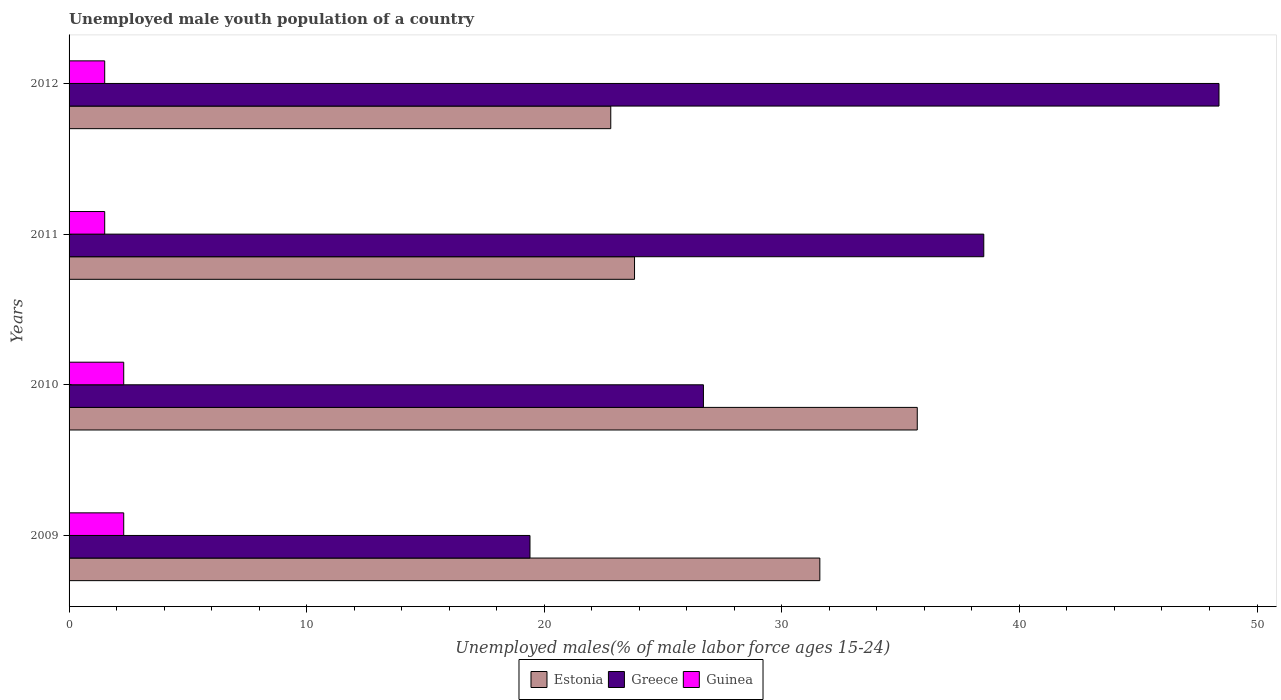How many different coloured bars are there?
Provide a short and direct response. 3. How many groups of bars are there?
Keep it short and to the point. 4. Are the number of bars per tick equal to the number of legend labels?
Make the answer very short. Yes. Are the number of bars on each tick of the Y-axis equal?
Provide a succinct answer. Yes. How many bars are there on the 2nd tick from the top?
Make the answer very short. 3. How many bars are there on the 3rd tick from the bottom?
Ensure brevity in your answer.  3. What is the percentage of unemployed male youth population in Guinea in 2009?
Give a very brief answer. 2.3. Across all years, what is the maximum percentage of unemployed male youth population in Guinea?
Your response must be concise. 2.3. Across all years, what is the minimum percentage of unemployed male youth population in Greece?
Ensure brevity in your answer.  19.4. In which year was the percentage of unemployed male youth population in Guinea maximum?
Keep it short and to the point. 2009. What is the total percentage of unemployed male youth population in Greece in the graph?
Ensure brevity in your answer.  133. What is the difference between the percentage of unemployed male youth population in Estonia in 2009 and that in 2010?
Provide a short and direct response. -4.1. What is the difference between the percentage of unemployed male youth population in Estonia in 2010 and the percentage of unemployed male youth population in Guinea in 2012?
Make the answer very short. 34.2. What is the average percentage of unemployed male youth population in Estonia per year?
Give a very brief answer. 28.47. In the year 2012, what is the difference between the percentage of unemployed male youth population in Guinea and percentage of unemployed male youth population in Estonia?
Ensure brevity in your answer.  -21.3. In how many years, is the percentage of unemployed male youth population in Guinea greater than 46 %?
Make the answer very short. 0. What is the ratio of the percentage of unemployed male youth population in Greece in 2009 to that in 2012?
Provide a succinct answer. 0.4. Is the percentage of unemployed male youth population in Estonia in 2010 less than that in 2012?
Your response must be concise. No. Is the difference between the percentage of unemployed male youth population in Guinea in 2010 and 2011 greater than the difference between the percentage of unemployed male youth population in Estonia in 2010 and 2011?
Offer a very short reply. No. What is the difference between the highest and the second highest percentage of unemployed male youth population in Guinea?
Give a very brief answer. 0. What is the difference between the highest and the lowest percentage of unemployed male youth population in Greece?
Make the answer very short. 29. What does the 1st bar from the top in 2010 represents?
Make the answer very short. Guinea. Are the values on the major ticks of X-axis written in scientific E-notation?
Give a very brief answer. No. Does the graph contain any zero values?
Make the answer very short. No. Does the graph contain grids?
Offer a terse response. No. Where does the legend appear in the graph?
Your answer should be compact. Bottom center. What is the title of the graph?
Offer a terse response. Unemployed male youth population of a country. What is the label or title of the X-axis?
Give a very brief answer. Unemployed males(% of male labor force ages 15-24). What is the Unemployed males(% of male labor force ages 15-24) of Estonia in 2009?
Provide a short and direct response. 31.6. What is the Unemployed males(% of male labor force ages 15-24) in Greece in 2009?
Your response must be concise. 19.4. What is the Unemployed males(% of male labor force ages 15-24) of Guinea in 2009?
Provide a short and direct response. 2.3. What is the Unemployed males(% of male labor force ages 15-24) in Estonia in 2010?
Provide a succinct answer. 35.7. What is the Unemployed males(% of male labor force ages 15-24) of Greece in 2010?
Your response must be concise. 26.7. What is the Unemployed males(% of male labor force ages 15-24) of Guinea in 2010?
Offer a terse response. 2.3. What is the Unemployed males(% of male labor force ages 15-24) of Estonia in 2011?
Your answer should be compact. 23.8. What is the Unemployed males(% of male labor force ages 15-24) of Greece in 2011?
Make the answer very short. 38.5. What is the Unemployed males(% of male labor force ages 15-24) in Estonia in 2012?
Your answer should be compact. 22.8. What is the Unemployed males(% of male labor force ages 15-24) in Greece in 2012?
Provide a short and direct response. 48.4. What is the Unemployed males(% of male labor force ages 15-24) of Guinea in 2012?
Provide a short and direct response. 1.5. Across all years, what is the maximum Unemployed males(% of male labor force ages 15-24) of Estonia?
Offer a terse response. 35.7. Across all years, what is the maximum Unemployed males(% of male labor force ages 15-24) of Greece?
Keep it short and to the point. 48.4. Across all years, what is the maximum Unemployed males(% of male labor force ages 15-24) of Guinea?
Offer a very short reply. 2.3. Across all years, what is the minimum Unemployed males(% of male labor force ages 15-24) of Estonia?
Your response must be concise. 22.8. Across all years, what is the minimum Unemployed males(% of male labor force ages 15-24) of Greece?
Offer a very short reply. 19.4. Across all years, what is the minimum Unemployed males(% of male labor force ages 15-24) of Guinea?
Give a very brief answer. 1.5. What is the total Unemployed males(% of male labor force ages 15-24) in Estonia in the graph?
Keep it short and to the point. 113.9. What is the total Unemployed males(% of male labor force ages 15-24) in Greece in the graph?
Give a very brief answer. 133. What is the difference between the Unemployed males(% of male labor force ages 15-24) in Greece in 2009 and that in 2011?
Ensure brevity in your answer.  -19.1. What is the difference between the Unemployed males(% of male labor force ages 15-24) of Guinea in 2009 and that in 2011?
Provide a short and direct response. 0.8. What is the difference between the Unemployed males(% of male labor force ages 15-24) of Estonia in 2009 and that in 2012?
Keep it short and to the point. 8.8. What is the difference between the Unemployed males(% of male labor force ages 15-24) in Greece in 2009 and that in 2012?
Provide a succinct answer. -29. What is the difference between the Unemployed males(% of male labor force ages 15-24) of Guinea in 2009 and that in 2012?
Provide a succinct answer. 0.8. What is the difference between the Unemployed males(% of male labor force ages 15-24) in Greece in 2010 and that in 2011?
Offer a terse response. -11.8. What is the difference between the Unemployed males(% of male labor force ages 15-24) of Greece in 2010 and that in 2012?
Offer a very short reply. -21.7. What is the difference between the Unemployed males(% of male labor force ages 15-24) of Guinea in 2010 and that in 2012?
Keep it short and to the point. 0.8. What is the difference between the Unemployed males(% of male labor force ages 15-24) of Greece in 2011 and that in 2012?
Your answer should be compact. -9.9. What is the difference between the Unemployed males(% of male labor force ages 15-24) of Guinea in 2011 and that in 2012?
Provide a succinct answer. 0. What is the difference between the Unemployed males(% of male labor force ages 15-24) in Estonia in 2009 and the Unemployed males(% of male labor force ages 15-24) in Guinea in 2010?
Keep it short and to the point. 29.3. What is the difference between the Unemployed males(% of male labor force ages 15-24) of Greece in 2009 and the Unemployed males(% of male labor force ages 15-24) of Guinea in 2010?
Give a very brief answer. 17.1. What is the difference between the Unemployed males(% of male labor force ages 15-24) in Estonia in 2009 and the Unemployed males(% of male labor force ages 15-24) in Greece in 2011?
Your answer should be very brief. -6.9. What is the difference between the Unemployed males(% of male labor force ages 15-24) in Estonia in 2009 and the Unemployed males(% of male labor force ages 15-24) in Guinea in 2011?
Give a very brief answer. 30.1. What is the difference between the Unemployed males(% of male labor force ages 15-24) of Greece in 2009 and the Unemployed males(% of male labor force ages 15-24) of Guinea in 2011?
Offer a terse response. 17.9. What is the difference between the Unemployed males(% of male labor force ages 15-24) in Estonia in 2009 and the Unemployed males(% of male labor force ages 15-24) in Greece in 2012?
Your response must be concise. -16.8. What is the difference between the Unemployed males(% of male labor force ages 15-24) of Estonia in 2009 and the Unemployed males(% of male labor force ages 15-24) of Guinea in 2012?
Provide a short and direct response. 30.1. What is the difference between the Unemployed males(% of male labor force ages 15-24) in Estonia in 2010 and the Unemployed males(% of male labor force ages 15-24) in Greece in 2011?
Your answer should be compact. -2.8. What is the difference between the Unemployed males(% of male labor force ages 15-24) in Estonia in 2010 and the Unemployed males(% of male labor force ages 15-24) in Guinea in 2011?
Your response must be concise. 34.2. What is the difference between the Unemployed males(% of male labor force ages 15-24) of Greece in 2010 and the Unemployed males(% of male labor force ages 15-24) of Guinea in 2011?
Make the answer very short. 25.2. What is the difference between the Unemployed males(% of male labor force ages 15-24) of Estonia in 2010 and the Unemployed males(% of male labor force ages 15-24) of Guinea in 2012?
Offer a very short reply. 34.2. What is the difference between the Unemployed males(% of male labor force ages 15-24) in Greece in 2010 and the Unemployed males(% of male labor force ages 15-24) in Guinea in 2012?
Make the answer very short. 25.2. What is the difference between the Unemployed males(% of male labor force ages 15-24) of Estonia in 2011 and the Unemployed males(% of male labor force ages 15-24) of Greece in 2012?
Your answer should be very brief. -24.6. What is the difference between the Unemployed males(% of male labor force ages 15-24) in Estonia in 2011 and the Unemployed males(% of male labor force ages 15-24) in Guinea in 2012?
Your response must be concise. 22.3. What is the average Unemployed males(% of male labor force ages 15-24) in Estonia per year?
Your answer should be compact. 28.48. What is the average Unemployed males(% of male labor force ages 15-24) in Greece per year?
Your answer should be compact. 33.25. In the year 2009, what is the difference between the Unemployed males(% of male labor force ages 15-24) in Estonia and Unemployed males(% of male labor force ages 15-24) in Guinea?
Your answer should be very brief. 29.3. In the year 2010, what is the difference between the Unemployed males(% of male labor force ages 15-24) in Estonia and Unemployed males(% of male labor force ages 15-24) in Greece?
Provide a short and direct response. 9. In the year 2010, what is the difference between the Unemployed males(% of male labor force ages 15-24) in Estonia and Unemployed males(% of male labor force ages 15-24) in Guinea?
Your response must be concise. 33.4. In the year 2010, what is the difference between the Unemployed males(% of male labor force ages 15-24) of Greece and Unemployed males(% of male labor force ages 15-24) of Guinea?
Ensure brevity in your answer.  24.4. In the year 2011, what is the difference between the Unemployed males(% of male labor force ages 15-24) in Estonia and Unemployed males(% of male labor force ages 15-24) in Greece?
Give a very brief answer. -14.7. In the year 2011, what is the difference between the Unemployed males(% of male labor force ages 15-24) in Estonia and Unemployed males(% of male labor force ages 15-24) in Guinea?
Offer a very short reply. 22.3. In the year 2012, what is the difference between the Unemployed males(% of male labor force ages 15-24) of Estonia and Unemployed males(% of male labor force ages 15-24) of Greece?
Provide a succinct answer. -25.6. In the year 2012, what is the difference between the Unemployed males(% of male labor force ages 15-24) in Estonia and Unemployed males(% of male labor force ages 15-24) in Guinea?
Keep it short and to the point. 21.3. In the year 2012, what is the difference between the Unemployed males(% of male labor force ages 15-24) in Greece and Unemployed males(% of male labor force ages 15-24) in Guinea?
Make the answer very short. 46.9. What is the ratio of the Unemployed males(% of male labor force ages 15-24) of Estonia in 2009 to that in 2010?
Ensure brevity in your answer.  0.89. What is the ratio of the Unemployed males(% of male labor force ages 15-24) in Greece in 2009 to that in 2010?
Keep it short and to the point. 0.73. What is the ratio of the Unemployed males(% of male labor force ages 15-24) in Estonia in 2009 to that in 2011?
Give a very brief answer. 1.33. What is the ratio of the Unemployed males(% of male labor force ages 15-24) in Greece in 2009 to that in 2011?
Give a very brief answer. 0.5. What is the ratio of the Unemployed males(% of male labor force ages 15-24) of Guinea in 2009 to that in 2011?
Keep it short and to the point. 1.53. What is the ratio of the Unemployed males(% of male labor force ages 15-24) in Estonia in 2009 to that in 2012?
Make the answer very short. 1.39. What is the ratio of the Unemployed males(% of male labor force ages 15-24) in Greece in 2009 to that in 2012?
Your answer should be very brief. 0.4. What is the ratio of the Unemployed males(% of male labor force ages 15-24) in Guinea in 2009 to that in 2012?
Give a very brief answer. 1.53. What is the ratio of the Unemployed males(% of male labor force ages 15-24) in Greece in 2010 to that in 2011?
Keep it short and to the point. 0.69. What is the ratio of the Unemployed males(% of male labor force ages 15-24) of Guinea in 2010 to that in 2011?
Offer a terse response. 1.53. What is the ratio of the Unemployed males(% of male labor force ages 15-24) of Estonia in 2010 to that in 2012?
Your answer should be compact. 1.57. What is the ratio of the Unemployed males(% of male labor force ages 15-24) in Greece in 2010 to that in 2012?
Make the answer very short. 0.55. What is the ratio of the Unemployed males(% of male labor force ages 15-24) in Guinea in 2010 to that in 2012?
Make the answer very short. 1.53. What is the ratio of the Unemployed males(% of male labor force ages 15-24) of Estonia in 2011 to that in 2012?
Make the answer very short. 1.04. What is the ratio of the Unemployed males(% of male labor force ages 15-24) in Greece in 2011 to that in 2012?
Your response must be concise. 0.8. What is the difference between the highest and the lowest Unemployed males(% of male labor force ages 15-24) of Guinea?
Keep it short and to the point. 0.8. 